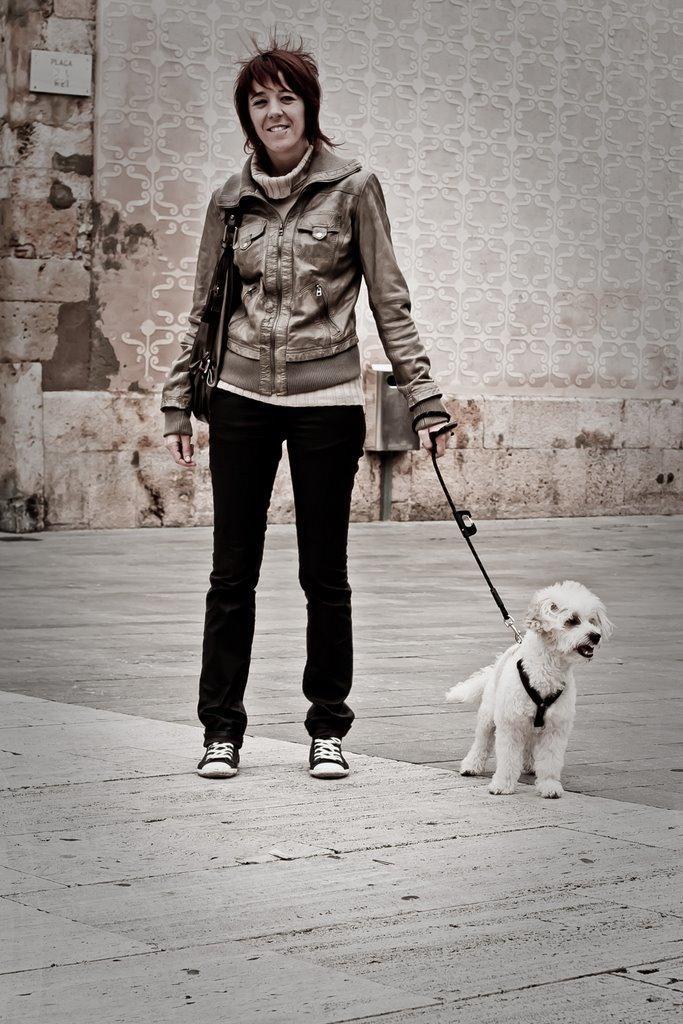How would you summarize this image in a sentence or two? In the center there is a person holding dog. In the back there's a wall with design. 